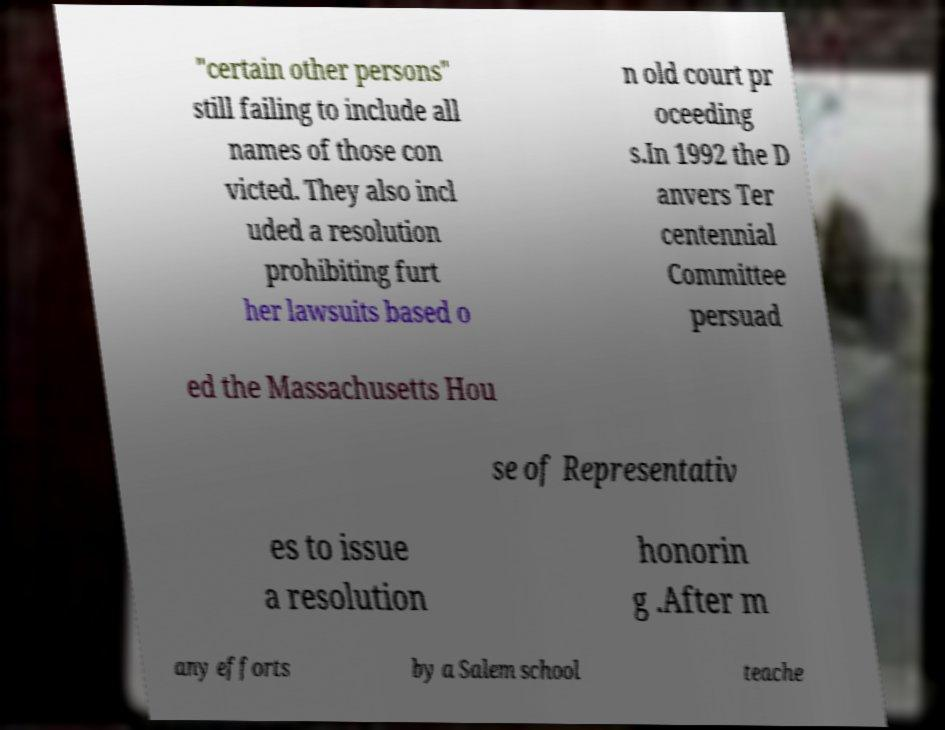Please read and relay the text visible in this image. What does it say? "certain other persons" still failing to include all names of those con victed. They also incl uded a resolution prohibiting furt her lawsuits based o n old court pr oceeding s.In 1992 the D anvers Ter centennial Committee persuad ed the Massachusetts Hou se of Representativ es to issue a resolution honorin g .After m any efforts by a Salem school teache 